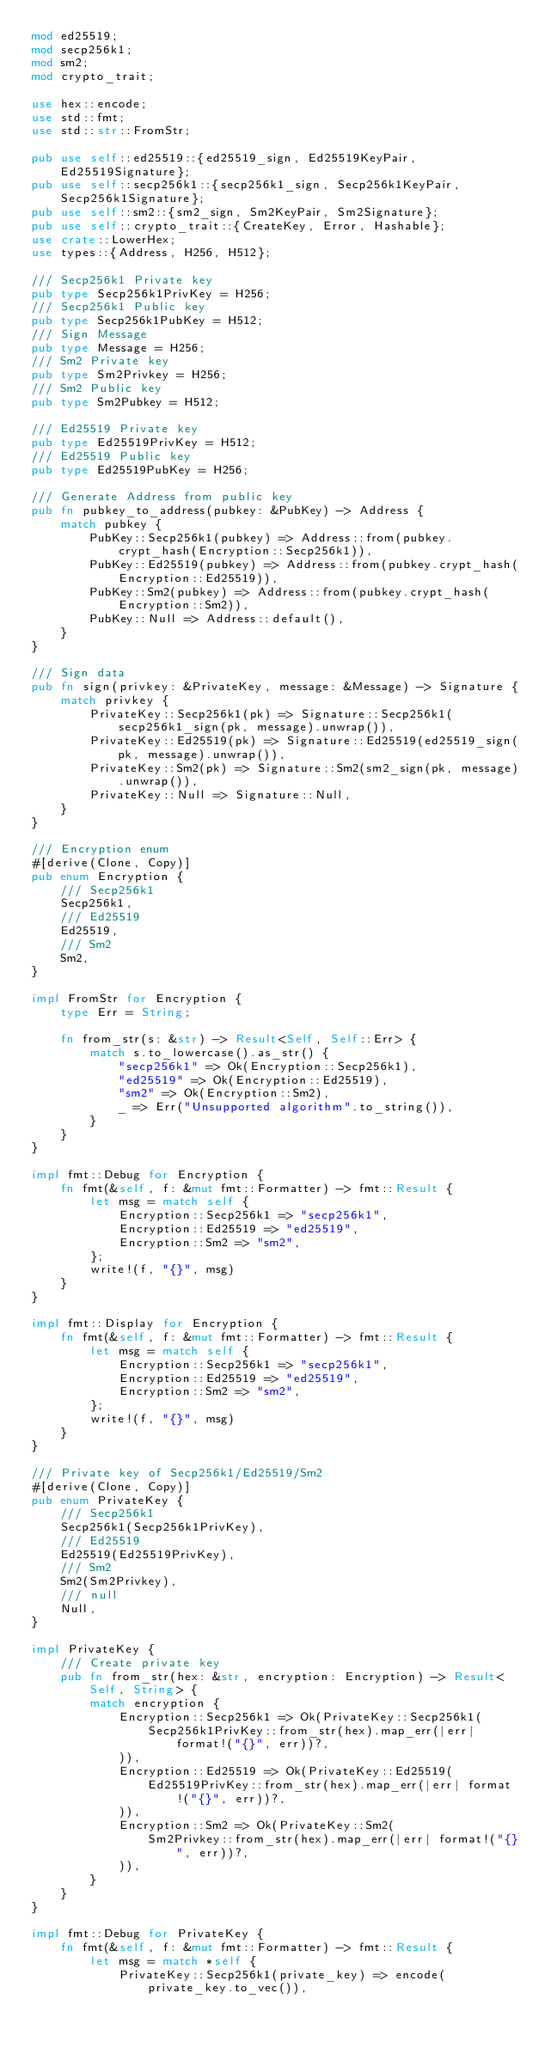<code> <loc_0><loc_0><loc_500><loc_500><_Rust_>mod ed25519;
mod secp256k1;
mod sm2;
mod crypto_trait;

use hex::encode;
use std::fmt;
use std::str::FromStr;

pub use self::ed25519::{ed25519_sign, Ed25519KeyPair, Ed25519Signature};
pub use self::secp256k1::{secp256k1_sign, Secp256k1KeyPair, Secp256k1Signature};
pub use self::sm2::{sm2_sign, Sm2KeyPair, Sm2Signature};
pub use self::crypto_trait::{CreateKey, Error, Hashable};
use crate::LowerHex;
use types::{Address, H256, H512};

/// Secp256k1 Private key
pub type Secp256k1PrivKey = H256;
/// Secp256k1 Public key
pub type Secp256k1PubKey = H512;
/// Sign Message
pub type Message = H256;
/// Sm2 Private key
pub type Sm2Privkey = H256;
/// Sm2 Public key
pub type Sm2Pubkey = H512;

/// Ed25519 Private key
pub type Ed25519PrivKey = H512;
/// Ed25519 Public key
pub type Ed25519PubKey = H256;

/// Generate Address from public key
pub fn pubkey_to_address(pubkey: &PubKey) -> Address {
    match pubkey {
        PubKey::Secp256k1(pubkey) => Address::from(pubkey.crypt_hash(Encryption::Secp256k1)),
        PubKey::Ed25519(pubkey) => Address::from(pubkey.crypt_hash(Encryption::Ed25519)),
        PubKey::Sm2(pubkey) => Address::from(pubkey.crypt_hash(Encryption::Sm2)),
        PubKey::Null => Address::default(),
    }
}

/// Sign data
pub fn sign(privkey: &PrivateKey, message: &Message) -> Signature {
    match privkey {
        PrivateKey::Secp256k1(pk) => Signature::Secp256k1(secp256k1_sign(pk, message).unwrap()),
        PrivateKey::Ed25519(pk) => Signature::Ed25519(ed25519_sign(pk, message).unwrap()),
        PrivateKey::Sm2(pk) => Signature::Sm2(sm2_sign(pk, message).unwrap()),
        PrivateKey::Null => Signature::Null,
    }
}

/// Encryption enum
#[derive(Clone, Copy)]
pub enum Encryption {
    /// Secp256k1
    Secp256k1,
    /// Ed25519
    Ed25519,
    /// Sm2
    Sm2,
}

impl FromStr for Encryption {
    type Err = String;

    fn from_str(s: &str) -> Result<Self, Self::Err> {
        match s.to_lowercase().as_str() {
            "secp256k1" => Ok(Encryption::Secp256k1),
            "ed25519" => Ok(Encryption::Ed25519),
            "sm2" => Ok(Encryption::Sm2),
            _ => Err("Unsupported algorithm".to_string()),
        }
    }
}

impl fmt::Debug for Encryption {
    fn fmt(&self, f: &mut fmt::Formatter) -> fmt::Result {
        let msg = match self {
            Encryption::Secp256k1 => "secp256k1",
            Encryption::Ed25519 => "ed25519",
            Encryption::Sm2 => "sm2",
        };
        write!(f, "{}", msg)
    }
}

impl fmt::Display for Encryption {
    fn fmt(&self, f: &mut fmt::Formatter) -> fmt::Result {
        let msg = match self {
            Encryption::Secp256k1 => "secp256k1",
            Encryption::Ed25519 => "ed25519",
            Encryption::Sm2 => "sm2",
        };
        write!(f, "{}", msg)
    }
}

/// Private key of Secp256k1/Ed25519/Sm2
#[derive(Clone, Copy)]
pub enum PrivateKey {
    /// Secp256k1
    Secp256k1(Secp256k1PrivKey),
    /// Ed25519
    Ed25519(Ed25519PrivKey),
    /// Sm2
    Sm2(Sm2Privkey),
    /// null
    Null,
}

impl PrivateKey {
    /// Create private key
    pub fn from_str(hex: &str, encryption: Encryption) -> Result<Self, String> {
        match encryption {
            Encryption::Secp256k1 => Ok(PrivateKey::Secp256k1(
                Secp256k1PrivKey::from_str(hex).map_err(|err| format!("{}", err))?,
            )),
            Encryption::Ed25519 => Ok(PrivateKey::Ed25519(
                Ed25519PrivKey::from_str(hex).map_err(|err| format!("{}", err))?,
            )),
            Encryption::Sm2 => Ok(PrivateKey::Sm2(
                Sm2Privkey::from_str(hex).map_err(|err| format!("{}", err))?,
            )),
        }
    }
}

impl fmt::Debug for PrivateKey {
    fn fmt(&self, f: &mut fmt::Formatter) -> fmt::Result {
        let msg = match *self {
            PrivateKey::Secp256k1(private_key) => encode(private_key.to_vec()),</code> 